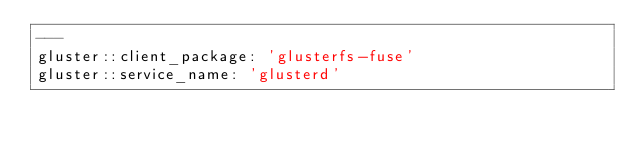Convert code to text. <code><loc_0><loc_0><loc_500><loc_500><_YAML_>---
gluster::client_package: 'glusterfs-fuse'
gluster::service_name: 'glusterd'
</code> 